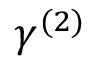Convert formula to latex. <formula><loc_0><loc_0><loc_500><loc_500>\gamma ^ { ( 2 ) }</formula> 